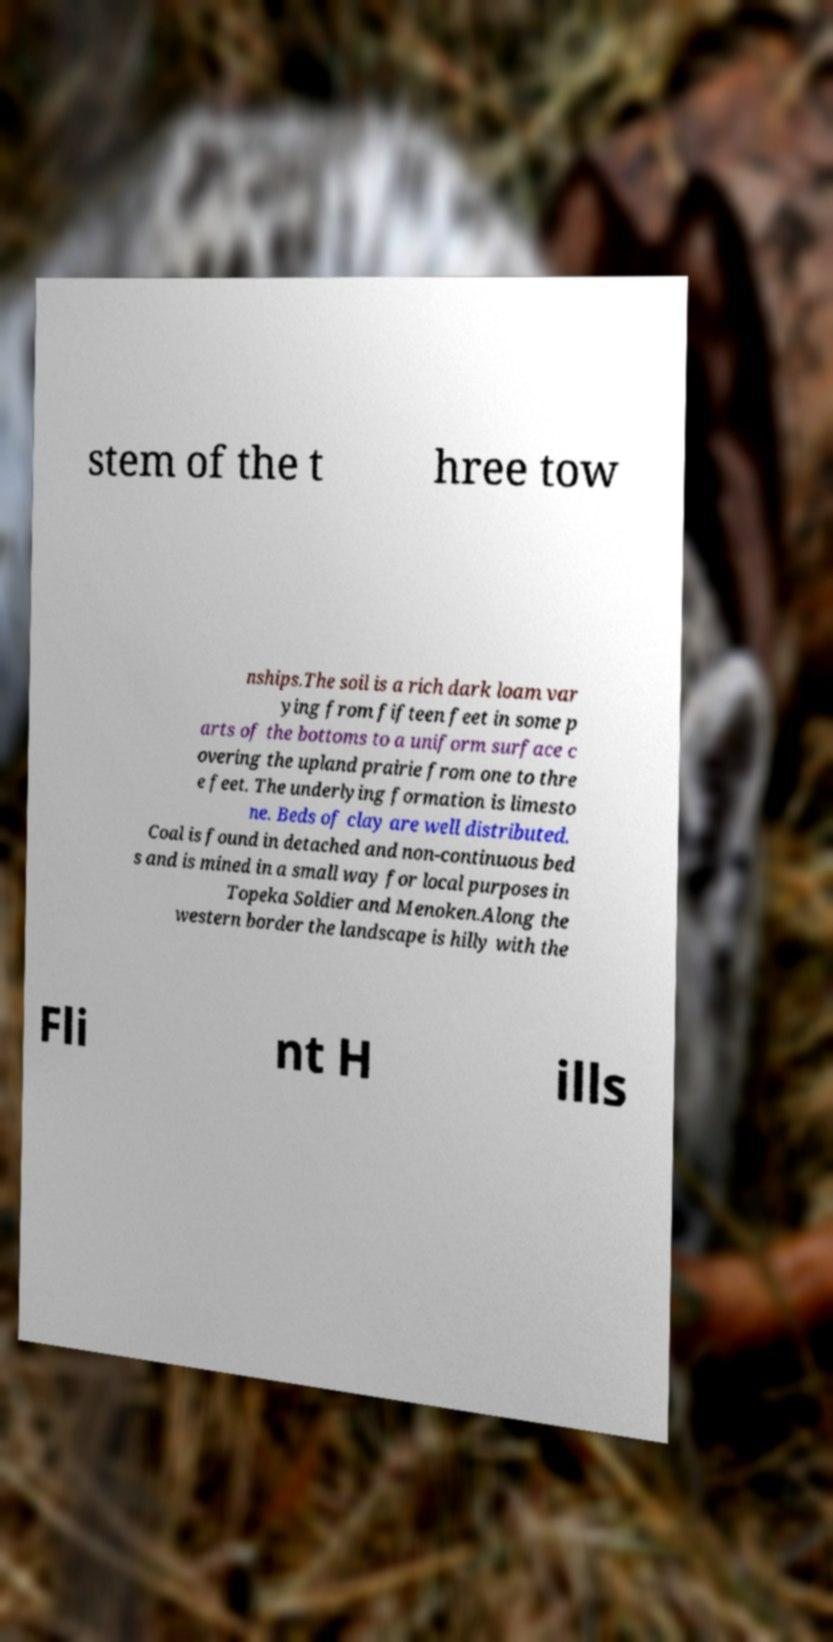I need the written content from this picture converted into text. Can you do that? stem of the t hree tow nships.The soil is a rich dark loam var ying from fifteen feet in some p arts of the bottoms to a uniform surface c overing the upland prairie from one to thre e feet. The underlying formation is limesto ne. Beds of clay are well distributed. Coal is found in detached and non-continuous bed s and is mined in a small way for local purposes in Topeka Soldier and Menoken.Along the western border the landscape is hilly with the Fli nt H ills 